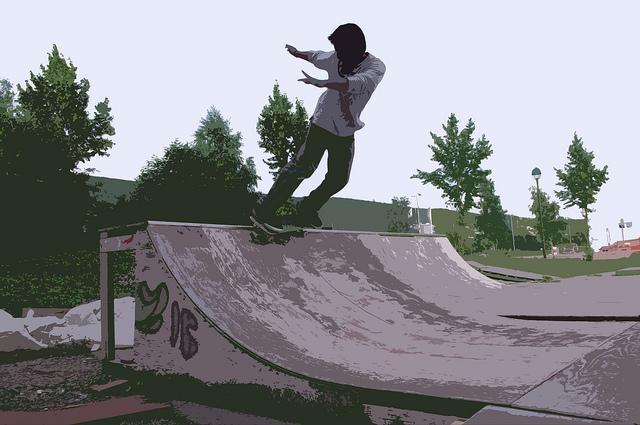How many trains are there?
Give a very brief answer. 0. 